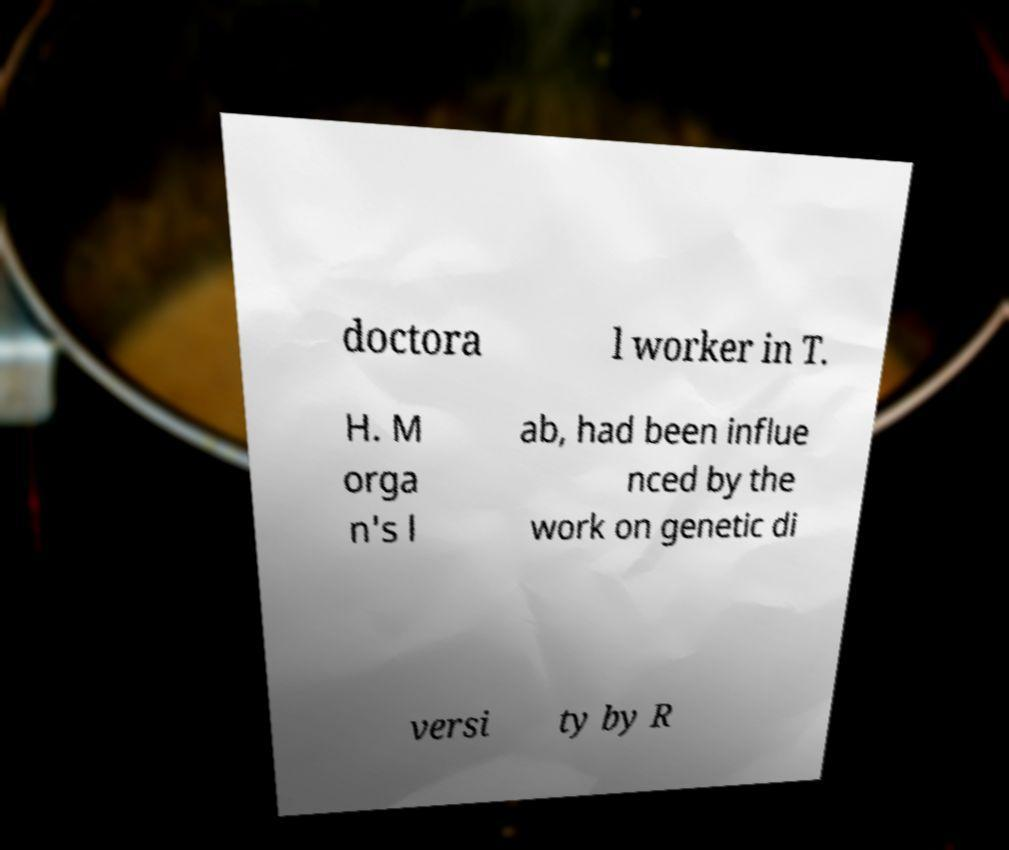Could you assist in decoding the text presented in this image and type it out clearly? doctora l worker in T. H. M orga n's l ab, had been influe nced by the work on genetic di versi ty by R 